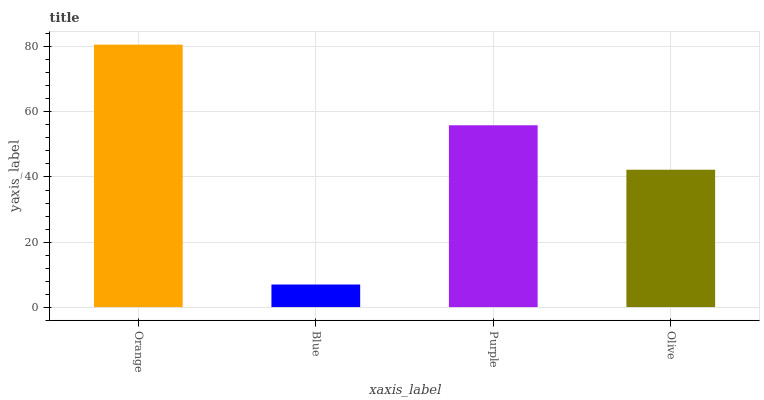Is Blue the minimum?
Answer yes or no. Yes. Is Orange the maximum?
Answer yes or no. Yes. Is Purple the minimum?
Answer yes or no. No. Is Purple the maximum?
Answer yes or no. No. Is Purple greater than Blue?
Answer yes or no. Yes. Is Blue less than Purple?
Answer yes or no. Yes. Is Blue greater than Purple?
Answer yes or no. No. Is Purple less than Blue?
Answer yes or no. No. Is Purple the high median?
Answer yes or no. Yes. Is Olive the low median?
Answer yes or no. Yes. Is Blue the high median?
Answer yes or no. No. Is Purple the low median?
Answer yes or no. No. 